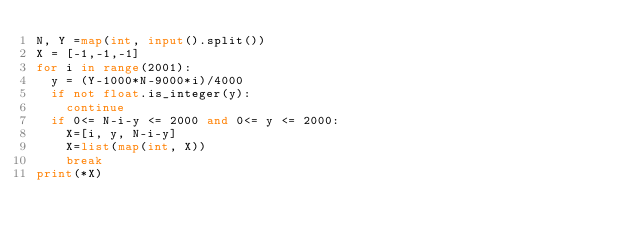Convert code to text. <code><loc_0><loc_0><loc_500><loc_500><_Python_>N, Y =map(int, input().split())
X = [-1,-1,-1]
for i in range(2001):
  y = (Y-1000*N-9000*i)/4000
  if not float.is_integer(y):
    continue
  if 0<= N-i-y <= 2000 and 0<= y <= 2000:
    X=[i, y, N-i-y]
    X=list(map(int, X))
    break
print(*X)
</code> 